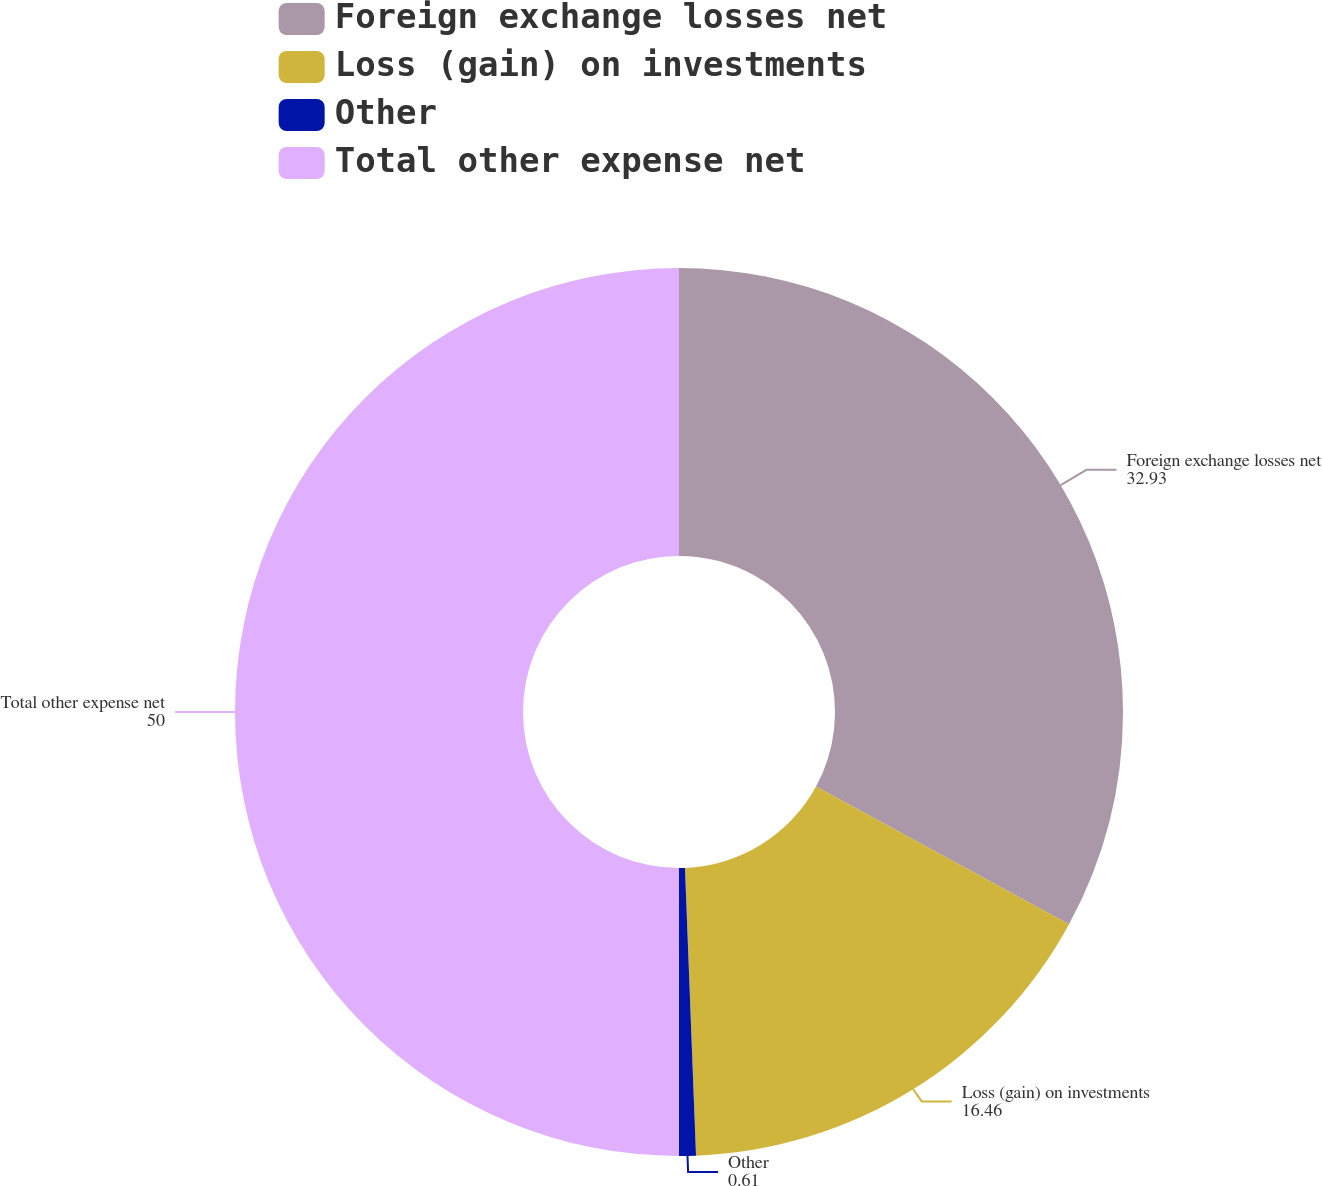Convert chart. <chart><loc_0><loc_0><loc_500><loc_500><pie_chart><fcel>Foreign exchange losses net<fcel>Loss (gain) on investments<fcel>Other<fcel>Total other expense net<nl><fcel>32.93%<fcel>16.46%<fcel>0.61%<fcel>50.0%<nl></chart> 